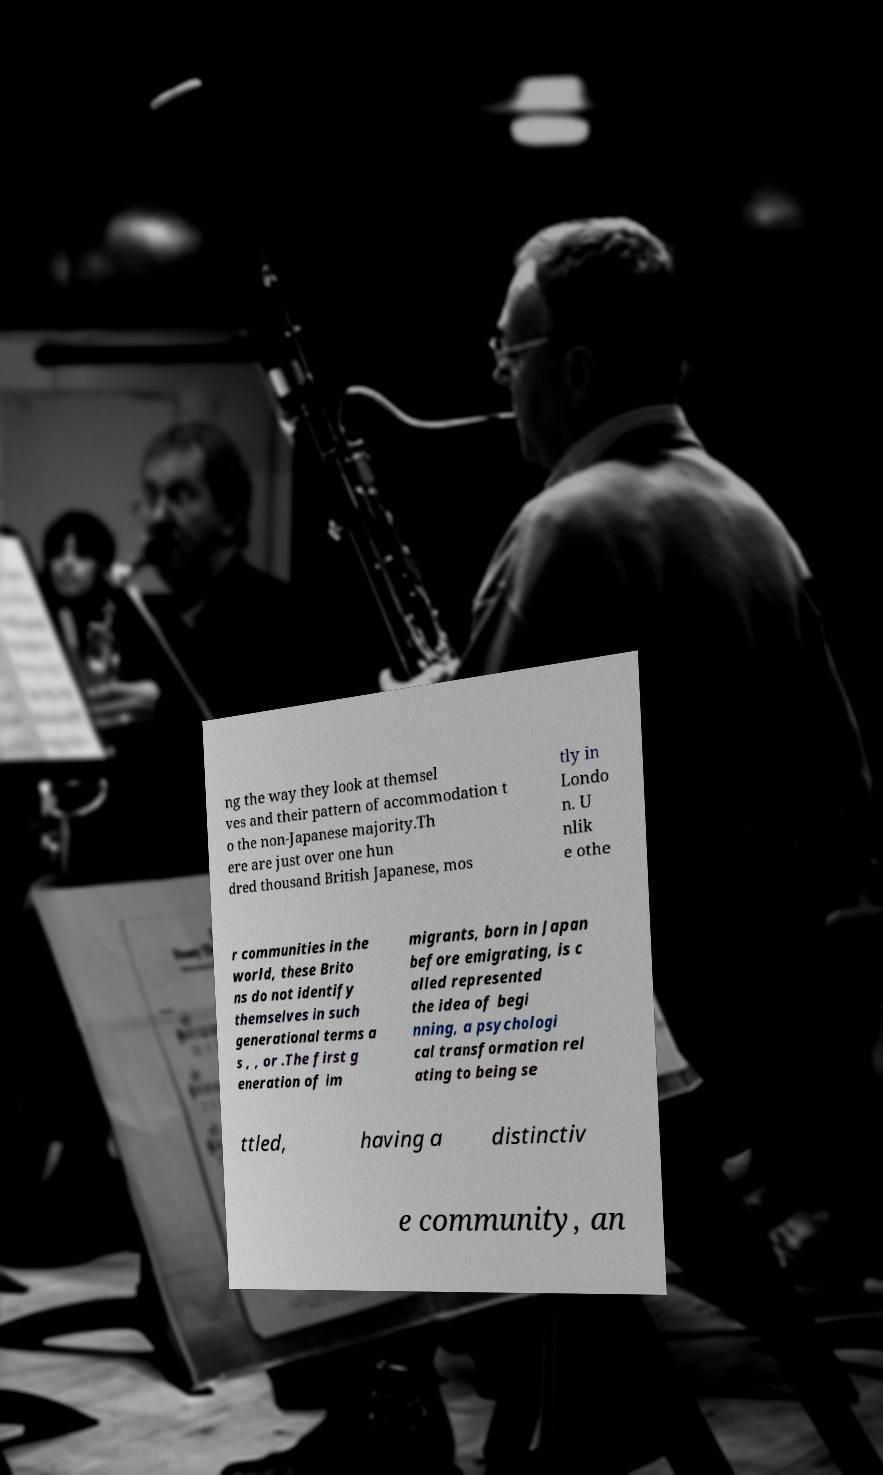What messages or text are displayed in this image? I need them in a readable, typed format. ng the way they look at themsel ves and their pattern of accommodation t o the non-Japanese majority.Th ere are just over one hun dred thousand British Japanese, mos tly in Londo n. U nlik e othe r communities in the world, these Brito ns do not identify themselves in such generational terms a s , , or .The first g eneration of im migrants, born in Japan before emigrating, is c alled represented the idea of begi nning, a psychologi cal transformation rel ating to being se ttled, having a distinctiv e community, an 